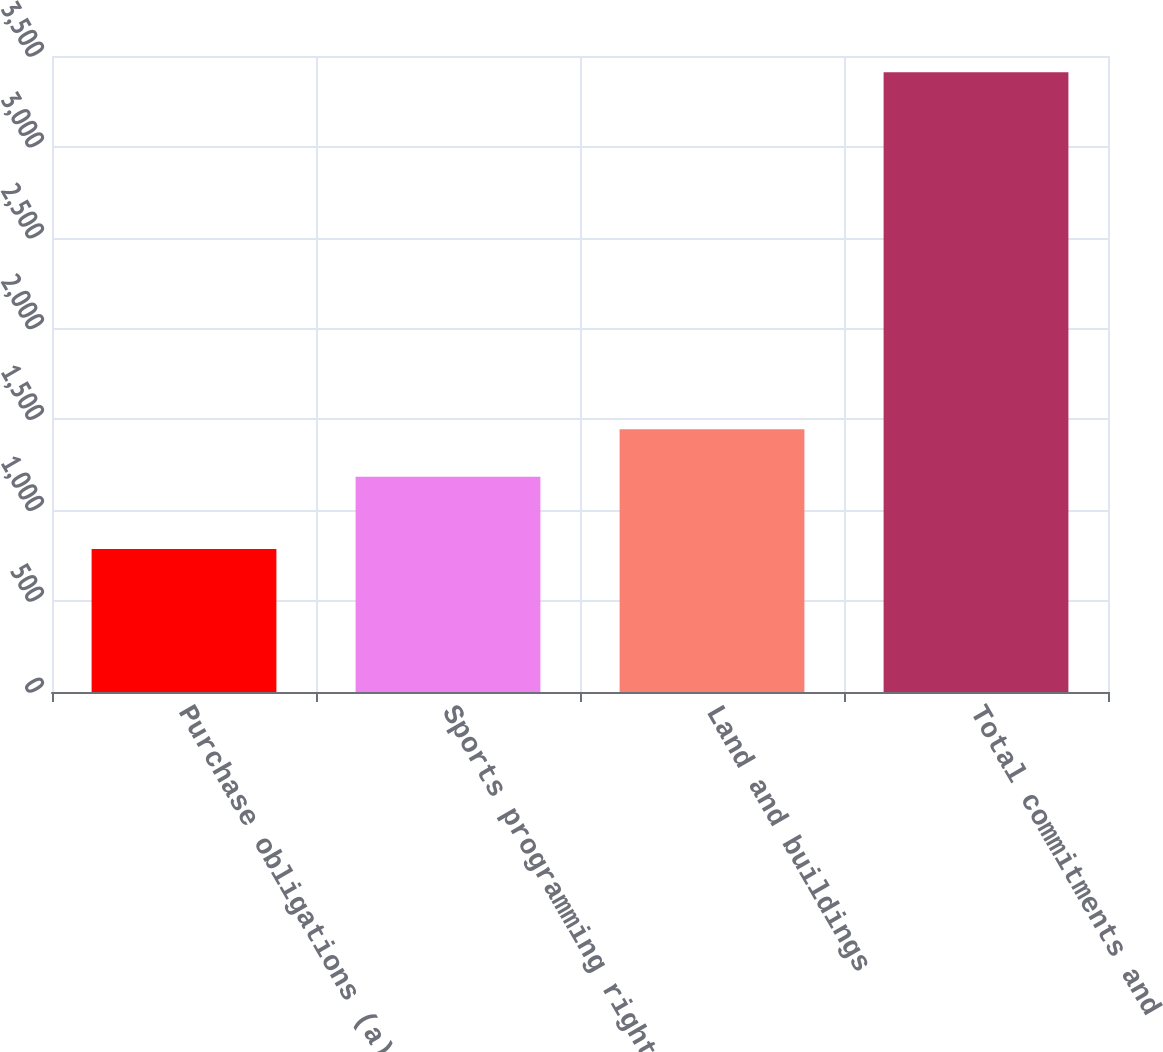<chart> <loc_0><loc_0><loc_500><loc_500><bar_chart><fcel>Purchase obligations (a)<fcel>Sports programming rights (b)<fcel>Land and buildings<fcel>Total commitments and<nl><fcel>787<fcel>1184<fcel>1446.4<fcel>3411<nl></chart> 